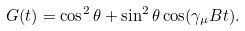<formula> <loc_0><loc_0><loc_500><loc_500>G ( t ) = \cos ^ { 2 } \theta + \sin ^ { 2 } \theta \cos ( \gamma _ { \mu } B t ) .</formula> 